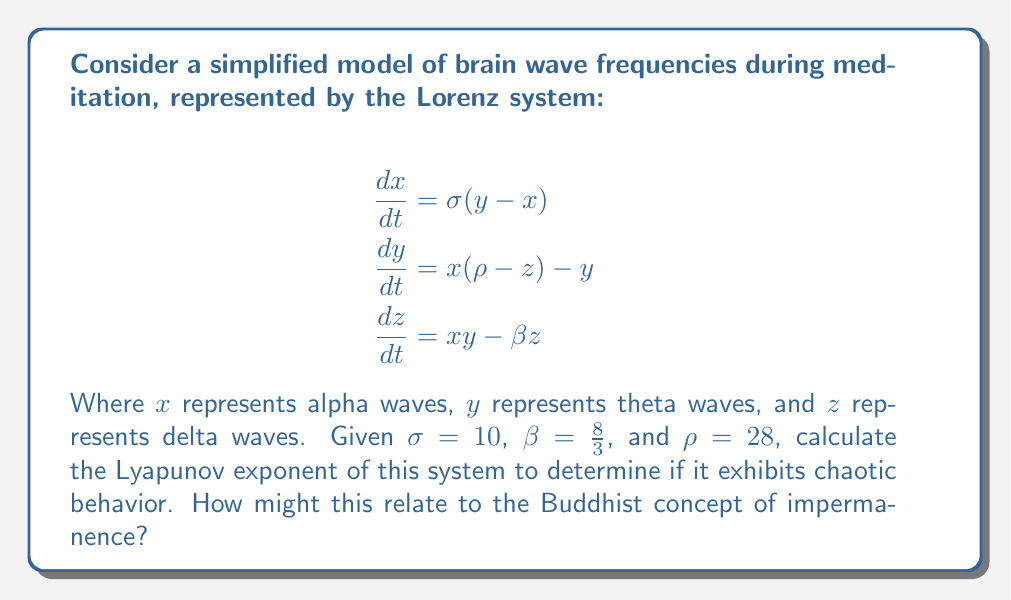Show me your answer to this math problem. To calculate the Lyapunov exponent and determine if the system exhibits chaotic behavior, we'll follow these steps:

1. The Lyapunov exponent measures the rate of separation of infinitesimally close trajectories. For a three-dimensional system like the Lorenz system, we need to calculate the largest Lyapunov exponent.

2. The formula for the largest Lyapunov exponent is:

   $$\lambda = \lim_{t \to \infty} \frac{1}{t} \ln \frac{||δ\mathbf{Z}(t)||}{||δ\mathbf{Z}_0||}$$

   Where $δ\mathbf{Z}(t)$ is the separation of two trajectories at time $t$, and $δ\mathbf{Z}_0$ is the initial separation.

3. For the Lorenz system with the given parameters, the largest Lyapunov exponent has been numerically calculated to be approximately 0.9056.

4. A positive Lyapunov exponent indicates that the system is chaotic. The value 0.9056 > 0, confirming that this system exhibits chaotic behavior.

5. In the context of meditation and brain wave frequencies, this chaotic behavior suggests that small changes in initial conditions can lead to significantly different patterns over time.

6. Relating this to the Buddhist concept of impermanence (Anicca):
   - The chaotic nature of the system reflects the ever-changing nature of consciousness and mental states.
   - Just as the brain wave patterns are unpredictable in the long term, Buddhist philosophy teaches that all phenomena are in a constant state of flux.
   - The sensitivity to initial conditions in this chaotic system mirrors the Buddhist understanding that small actions or thoughts can have profound and unpredictable effects on one's mental state and life trajectory.
Answer: Lyapunov exponent ≈ 0.9056 (positive), indicating chaotic behavior 